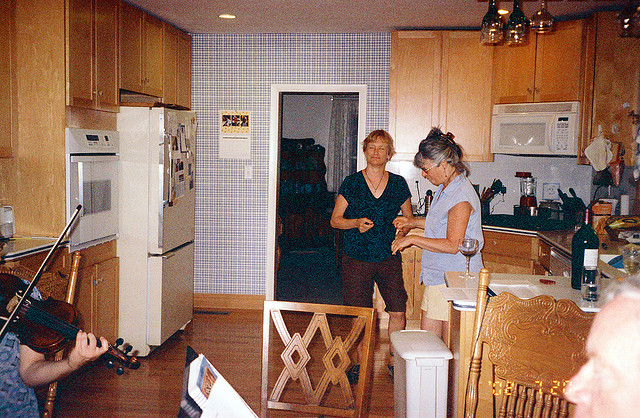How does the music contribute to this scene? Music often serves as a backdrop that enhances the atmosphere of social gatherings. In this case, the violin being played likely offers a soothing or lively soundtrack to the event, fostering a sense of togetherness and enhancing the ambiance of the moment. It adds a personal touch to the gathering, making it feel more intimate and special. 